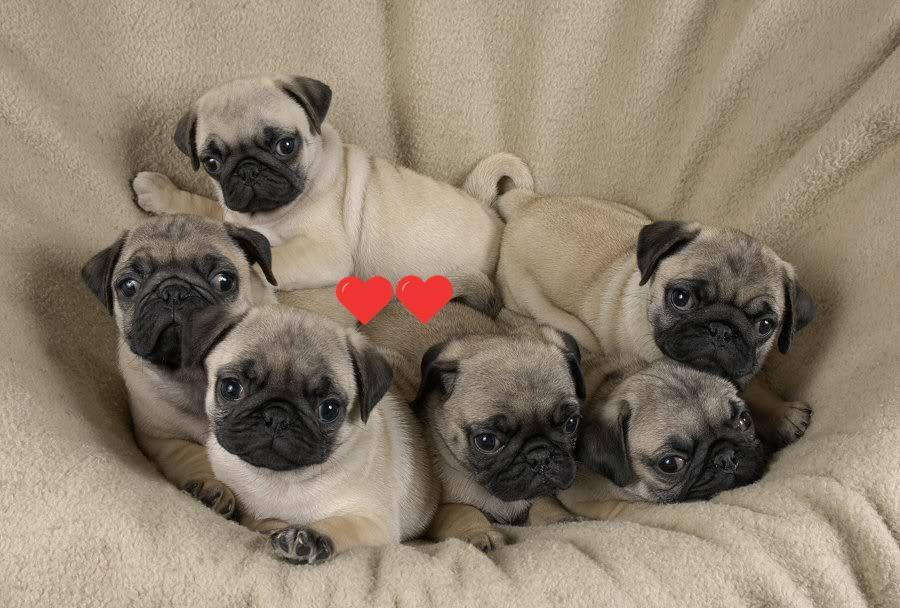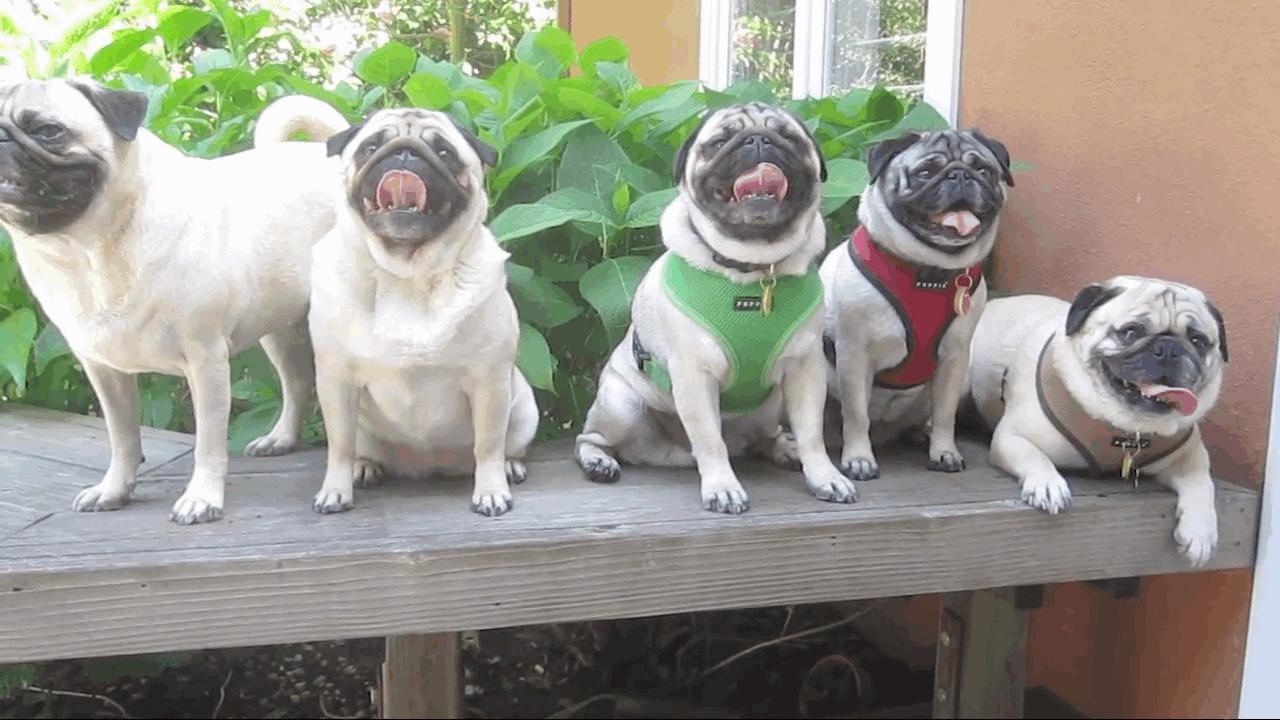The first image is the image on the left, the second image is the image on the right. For the images shown, is this caption "There are more pug dogs in the right image than in the left." true? Answer yes or no. No. The first image is the image on the left, the second image is the image on the right. Considering the images on both sides, is "All of the dogs are the same color and none of them are tied on a leash." valid? Answer yes or no. Yes. 